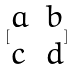Convert formula to latex. <formula><loc_0><loc_0><loc_500><loc_500>[ \begin{matrix} a & b \\ c & d \end{matrix} ]</formula> 